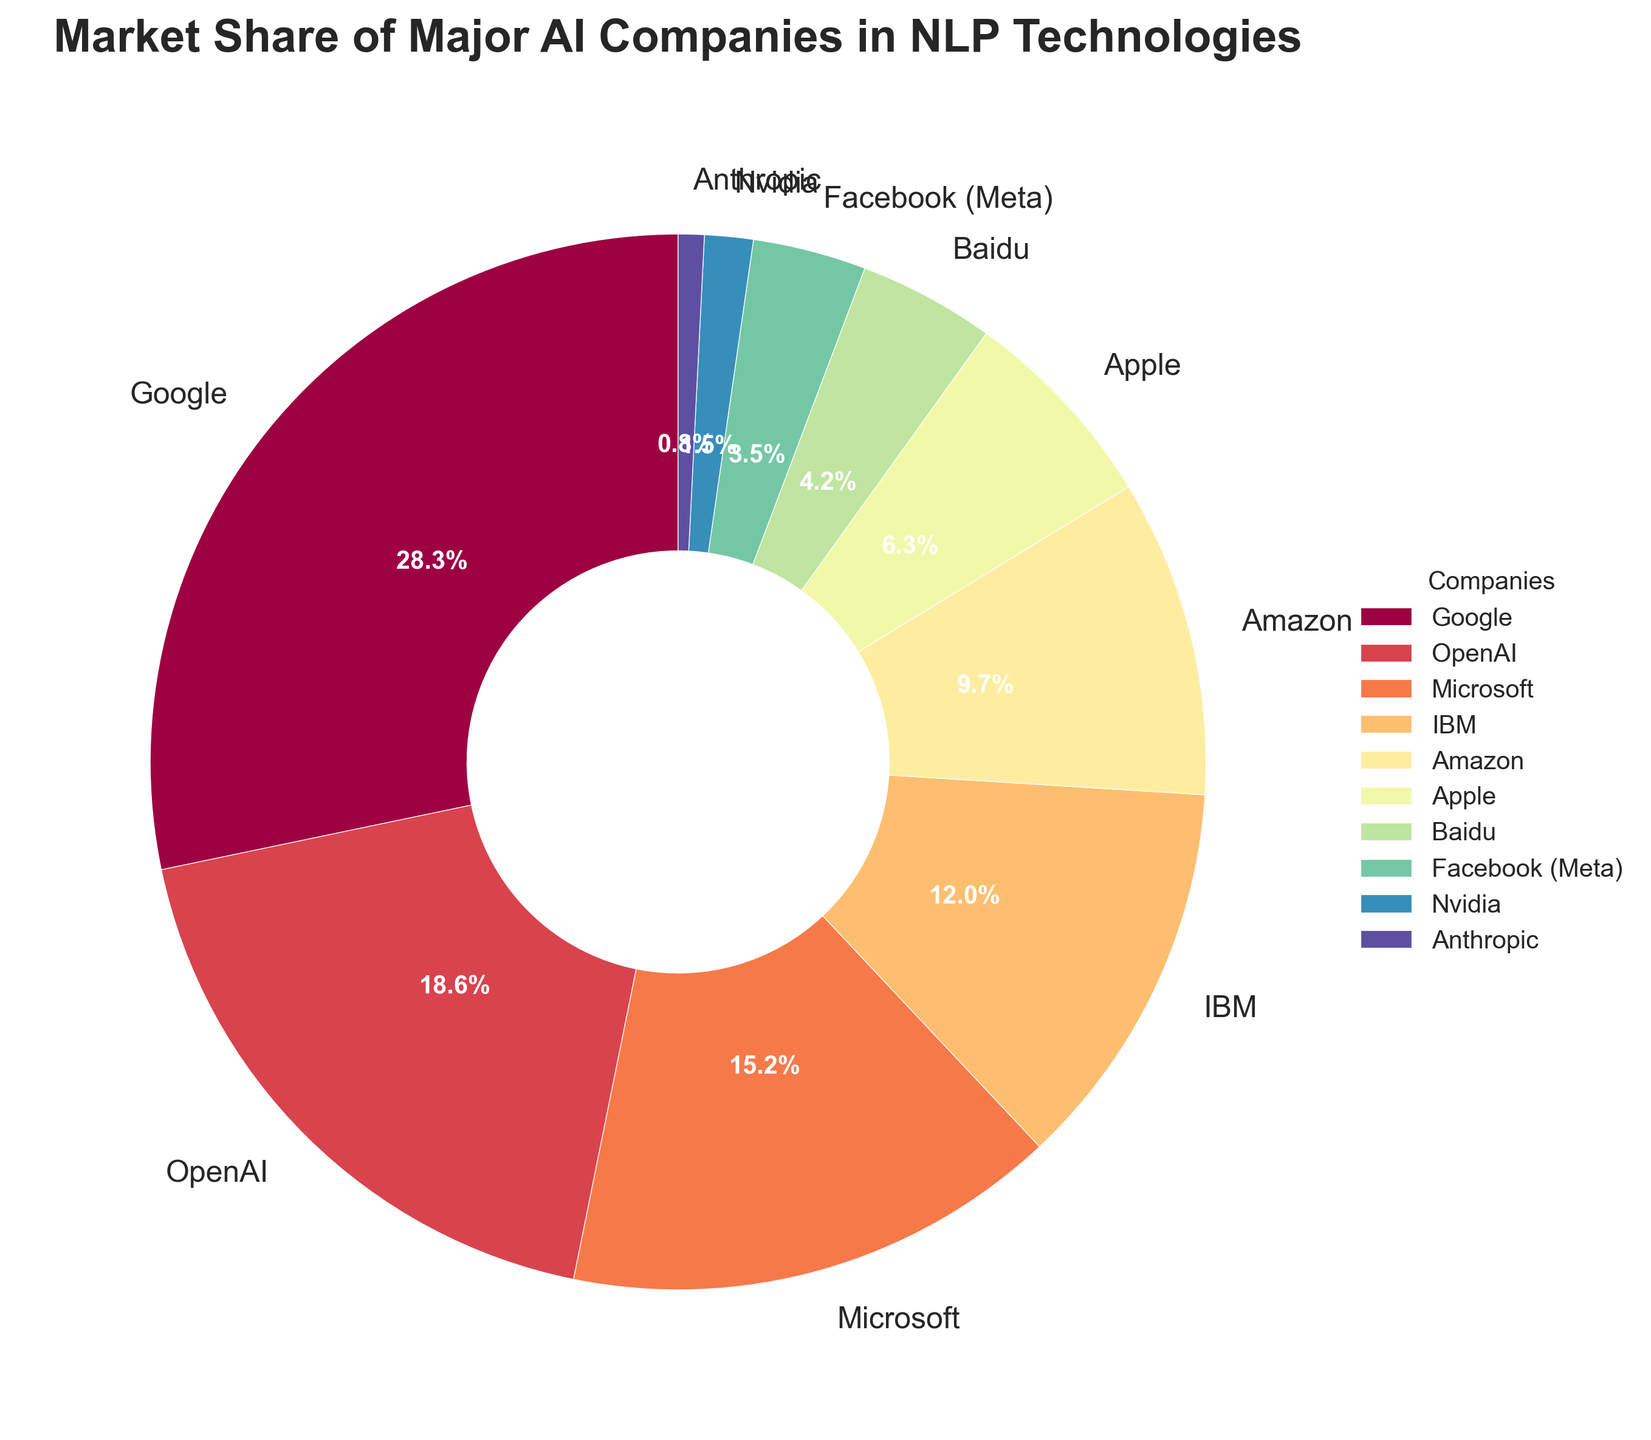Which company holds the largest market share in NLP technologies? The company with the largest wedge in the pie chart represents the largest market share. Googling at the chart, Google has the largest wedge.
Answer: Google Which company has the smallest market share? The company with the smallest segment in the pie chart represents the smallest market share. Anthropic has the smallest wedge.
Answer: Anthropic How much more market share does Google have compared to OpenAI? Google's market share is 28.5%, and OpenAI's market share is 18.7%. Subtract OpenAI's share from Google’s share: 28.5% - 18.7% = 9.8%.
Answer: 9.8% What is the combined market share of Microsoft and Amazon? Microsoft has a market share of 15.3%, and Amazon has a market share of 9.8%. Add these two percentages: 15.3% + 9.8% = 25.1%.
Answer: 25.1% Which company, IBM or Baidu, has a larger market share, and by how much? IBM's market share is 12.1%, and Baidu's market share is 4.2%. Subtract Baidu's share from IBM’s share: 12.1% - 4.2% = 7.9%.
Answer: IBM, 7.9% If Apple and Nvidia combined their market share, would they surpass Microsoft? Apple's market share is 6.4%, and Nvidia's market share is 1.5%. Combined, they have: 6.4% + 1.5% = 7.9%. Microsoft's market share is 15.3%. 7.9% < 15.3%, so they would not surpass Microsoft.
Answer: No What visual feature indicates the most significant market share? The largest wedge in the pie chart represents the most significant market share.
Answer: Largest Wedge Which two companies have a combined market share closest to 20%? Let's sum the market shares of the companies in pairs: IBM (12.1%) + Amazon (9.8%) = 21.9%; OpenAI (18.7%) + Anthropic (0.8%) = 19.5%; Apple (6.4%) + Baidu (4.2%) = 10.6%. The pair closest to 20% is OpenAI and Anthropic at 19.5%.
Answer: OpenAI and Anthropic Is the market share of Apple greater or less than half of Microsoft's market share? Half of Microsoft's market share is 15.3% / 2 = 7.65%. Apple's market share is 6.4%, which is less than 7.65%.
Answer: Less 